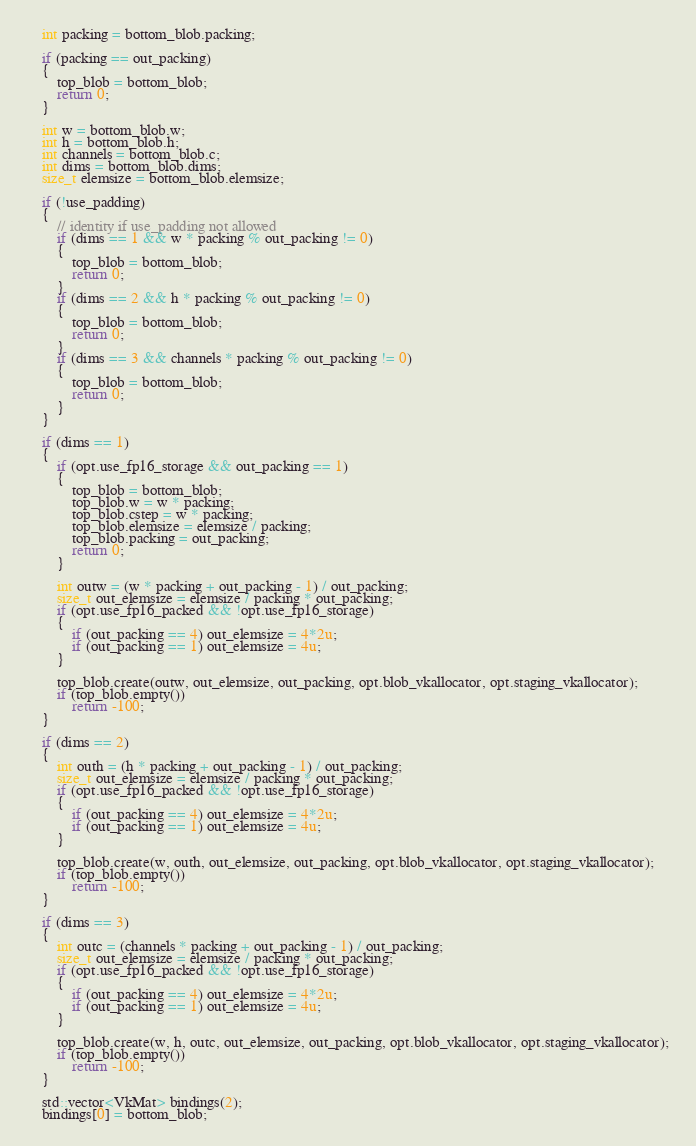<code> <loc_0><loc_0><loc_500><loc_500><_C++_>    int packing = bottom_blob.packing;

    if (packing == out_packing)
    {
        top_blob = bottom_blob;
        return 0;
    }

    int w = bottom_blob.w;
    int h = bottom_blob.h;
    int channels = bottom_blob.c;
    int dims = bottom_blob.dims;
    size_t elemsize = bottom_blob.elemsize;

    if (!use_padding)
    {
        // identity if use_padding not allowed
        if (dims == 1 && w * packing % out_packing != 0)
        {
            top_blob = bottom_blob;
            return 0;
        }
        if (dims == 2 && h * packing % out_packing != 0)
        {
            top_blob = bottom_blob;
            return 0;
        }
        if (dims == 3 && channels * packing % out_packing != 0)
        {
            top_blob = bottom_blob;
            return 0;
        }
    }

    if (dims == 1)
    {
        if (opt.use_fp16_storage && out_packing == 1)
        {
            top_blob = bottom_blob;
            top_blob.w = w * packing;
            top_blob.cstep = w * packing;
            top_blob.elemsize = elemsize / packing;
            top_blob.packing = out_packing;
            return 0;
        }

        int outw = (w * packing + out_packing - 1) / out_packing;
        size_t out_elemsize = elemsize / packing * out_packing;
        if (opt.use_fp16_packed && !opt.use_fp16_storage)
        {
            if (out_packing == 4) out_elemsize = 4*2u;
            if (out_packing == 1) out_elemsize = 4u;
        }

        top_blob.create(outw, out_elemsize, out_packing, opt.blob_vkallocator, opt.staging_vkallocator);
        if (top_blob.empty())
            return -100;
    }

    if (dims == 2)
    {
        int outh = (h * packing + out_packing - 1) / out_packing;
        size_t out_elemsize = elemsize / packing * out_packing;
        if (opt.use_fp16_packed && !opt.use_fp16_storage)
        {
            if (out_packing == 4) out_elemsize = 4*2u;
            if (out_packing == 1) out_elemsize = 4u;
        }

        top_blob.create(w, outh, out_elemsize, out_packing, opt.blob_vkallocator, opt.staging_vkallocator);
        if (top_blob.empty())
            return -100;
    }

    if (dims == 3)
    {
        int outc = (channels * packing + out_packing - 1) / out_packing;
        size_t out_elemsize = elemsize / packing * out_packing;
        if (opt.use_fp16_packed && !opt.use_fp16_storage)
        {
            if (out_packing == 4) out_elemsize = 4*2u;
            if (out_packing == 1) out_elemsize = 4u;
        }

        top_blob.create(w, h, outc, out_elemsize, out_packing, opt.blob_vkallocator, opt.staging_vkallocator);
        if (top_blob.empty())
            return -100;
    }

    std::vector<VkMat> bindings(2);
    bindings[0] = bottom_blob;</code> 